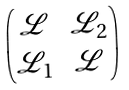<formula> <loc_0><loc_0><loc_500><loc_500>\begin{pmatrix} \mathcal { L } & \mathcal { L } _ { 2 } \\ \mathcal { L } _ { 1 } & \mathcal { L } \end{pmatrix}</formula> 